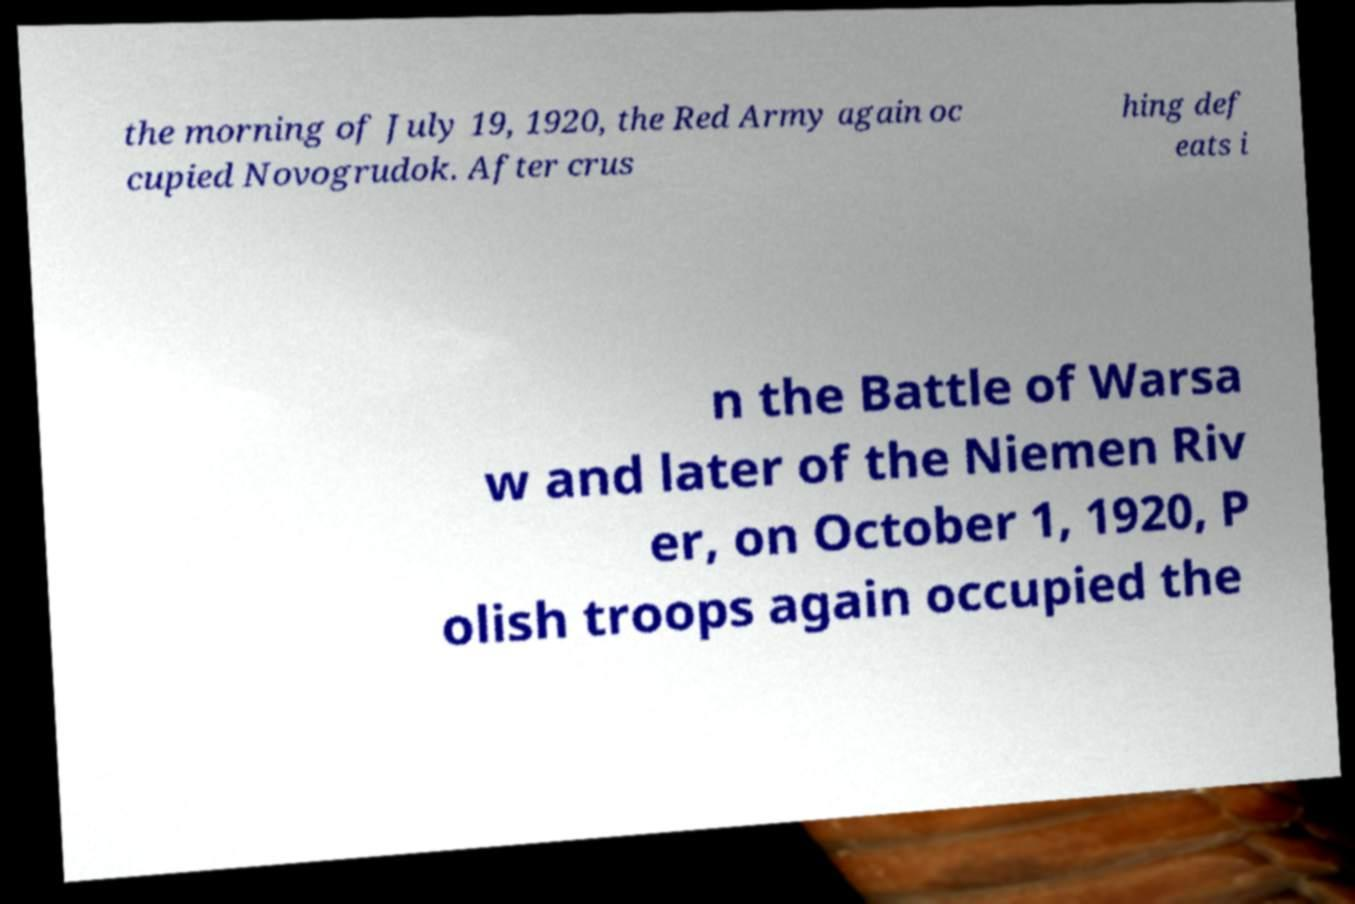What messages or text are displayed in this image? I need them in a readable, typed format. the morning of July 19, 1920, the Red Army again oc cupied Novogrudok. After crus hing def eats i n the Battle of Warsa w and later of the Niemen Riv er, on October 1, 1920, P olish troops again occupied the 